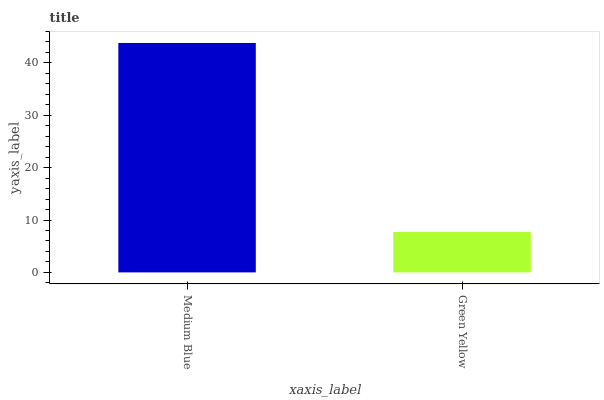Is Green Yellow the maximum?
Answer yes or no. No. Is Medium Blue greater than Green Yellow?
Answer yes or no. Yes. Is Green Yellow less than Medium Blue?
Answer yes or no. Yes. Is Green Yellow greater than Medium Blue?
Answer yes or no. No. Is Medium Blue less than Green Yellow?
Answer yes or no. No. Is Medium Blue the high median?
Answer yes or no. Yes. Is Green Yellow the low median?
Answer yes or no. Yes. Is Green Yellow the high median?
Answer yes or no. No. Is Medium Blue the low median?
Answer yes or no. No. 